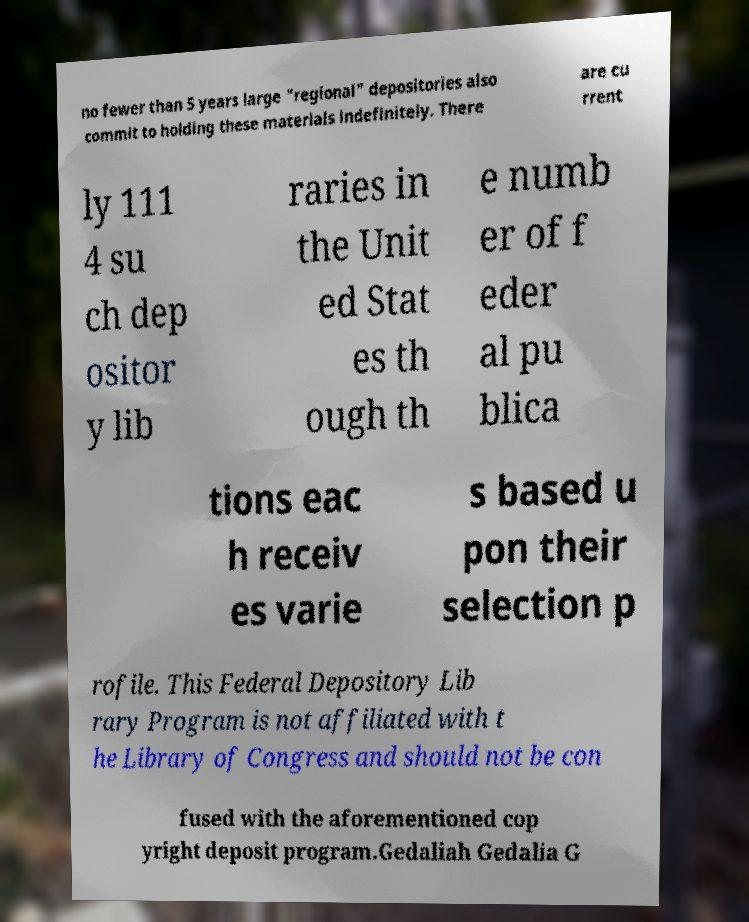Can you accurately transcribe the text from the provided image for me? no fewer than 5 years large "regional" depositories also commit to holding these materials indefinitely. There are cu rrent ly 111 4 su ch dep ositor y lib raries in the Unit ed Stat es th ough th e numb er of f eder al pu blica tions eac h receiv es varie s based u pon their selection p rofile. This Federal Depository Lib rary Program is not affiliated with t he Library of Congress and should not be con fused with the aforementioned cop yright deposit program.Gedaliah Gedalia G 